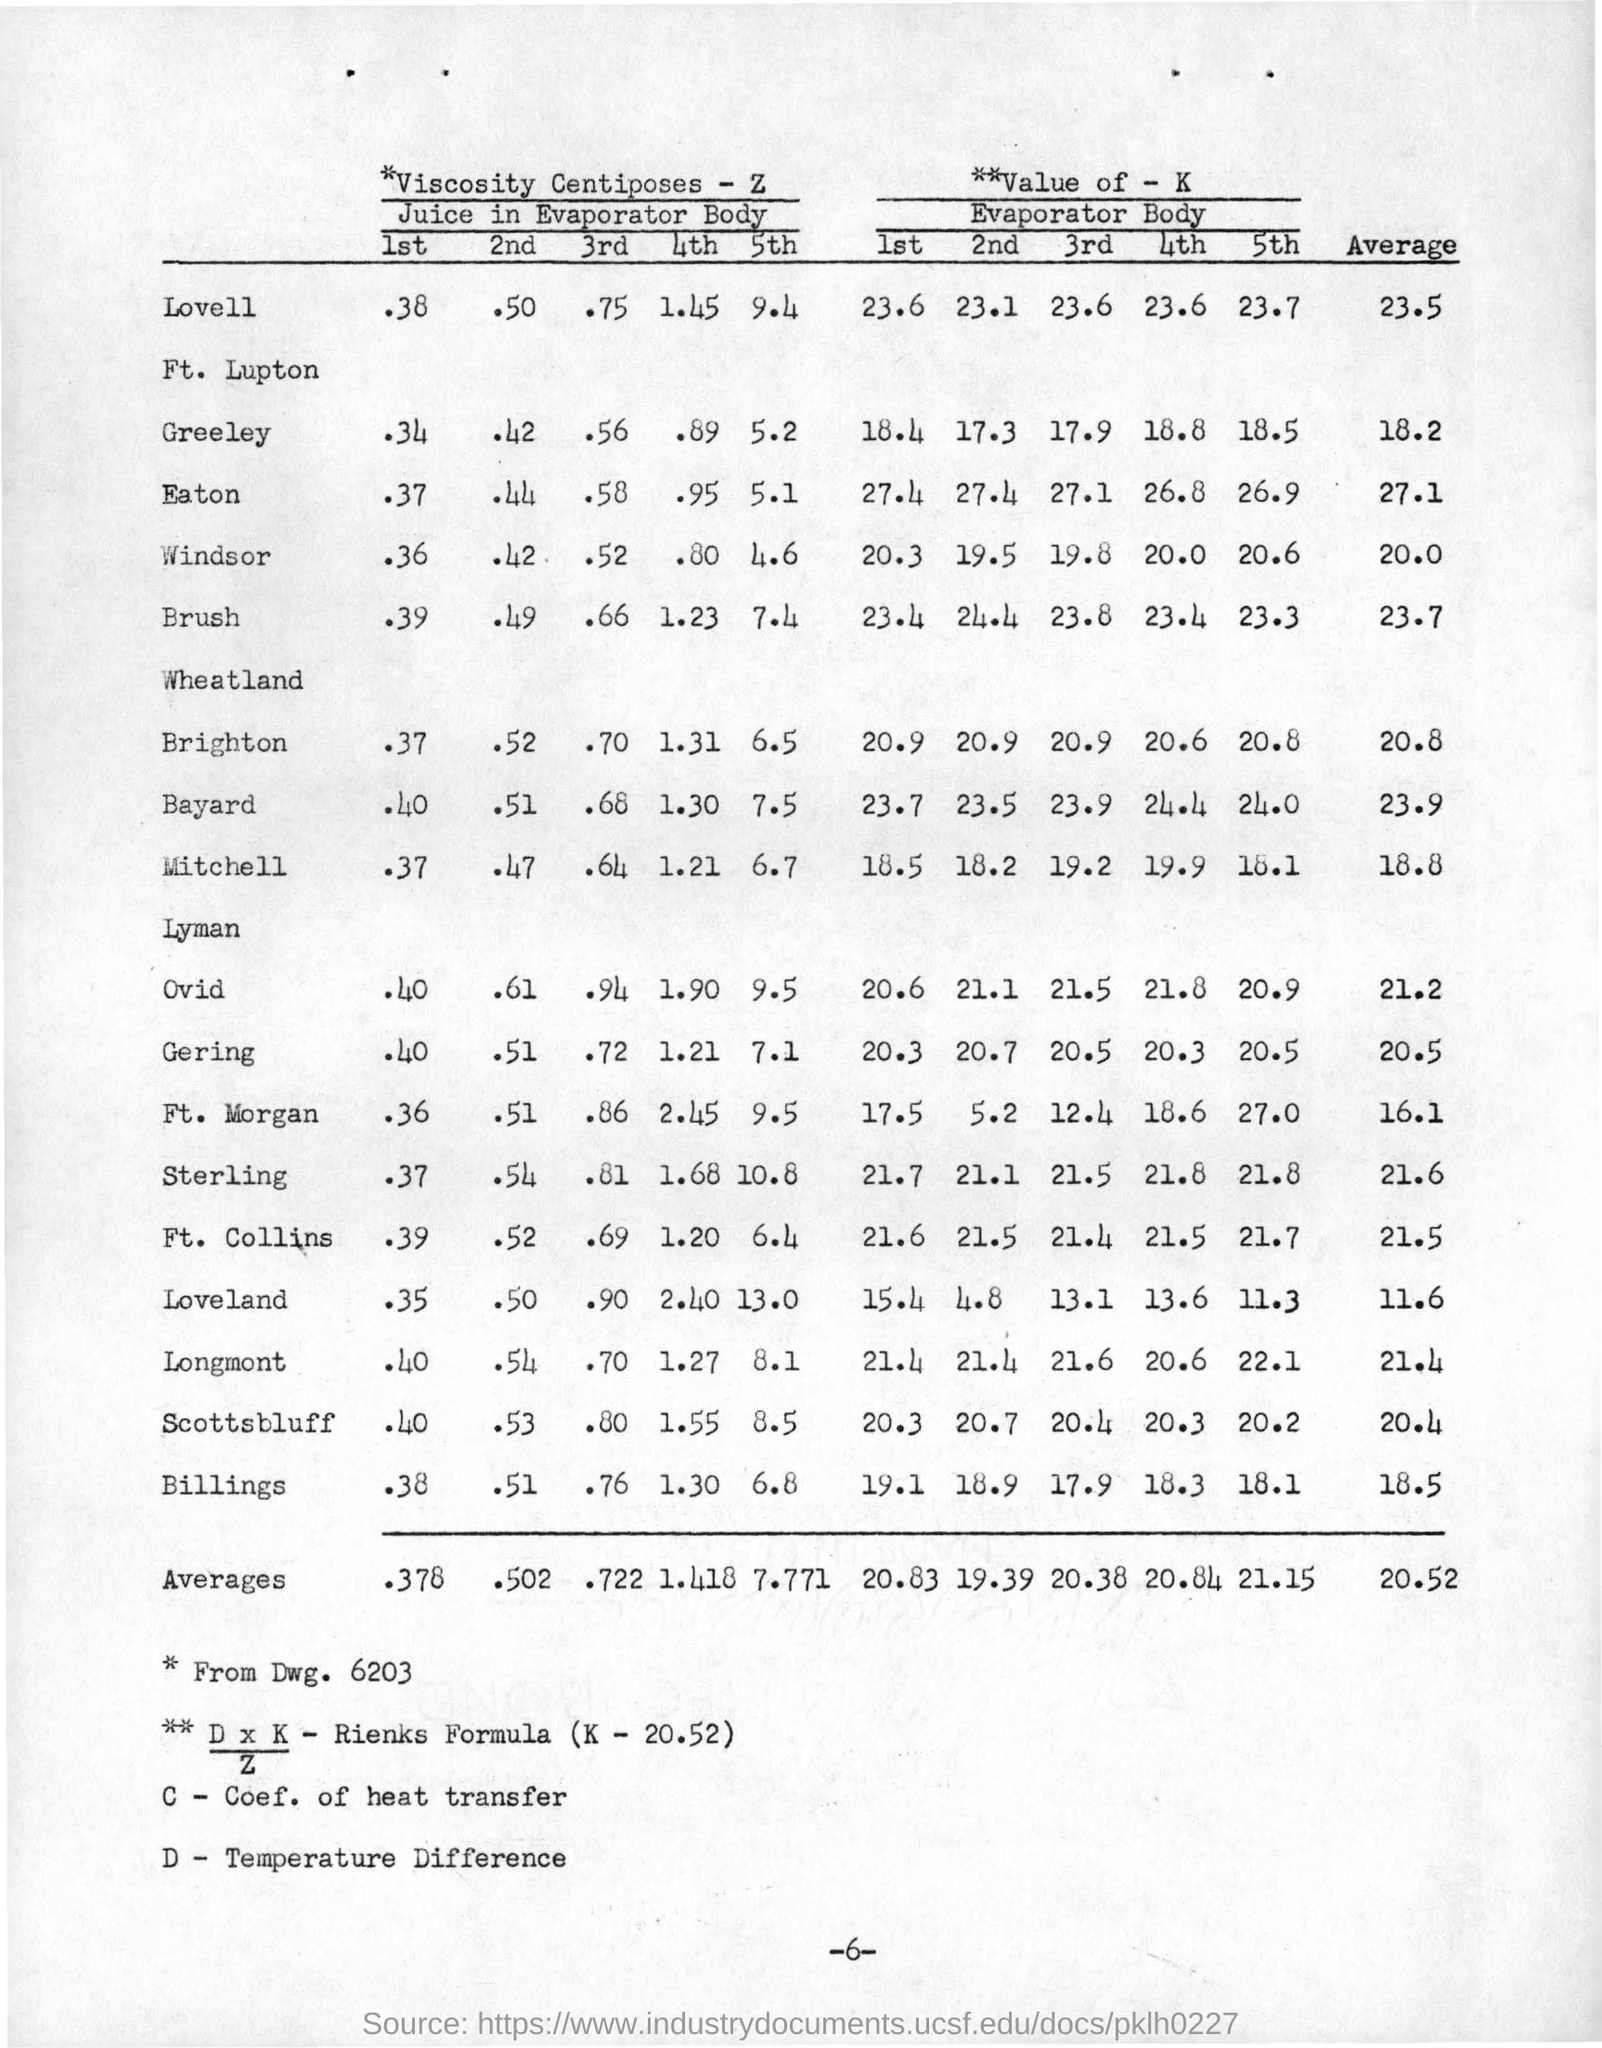Specify some key components in this picture. The value of K in Rienks Formula is 20.52. 